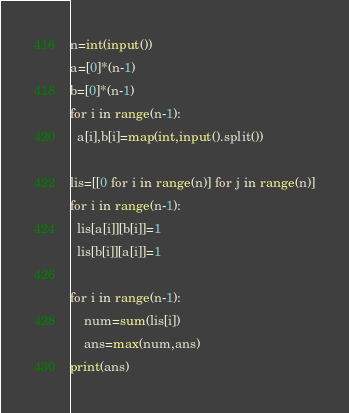<code> <loc_0><loc_0><loc_500><loc_500><_Python_>n=int(input())
a=[0]*(n-1)
b=[0]*(n-1)
for i in range(n-1):
  a[i],b[i]=map(int,input().split())
  
lis=[[0 for i in range(n)] for j in range(n)]
for i in range(n-1):
  lis[a[i]][b[i]]=1
  lis[b[i]][a[i]]=1

for i in range(n-1):
	num=sum(lis[i])
    ans=max(num,ans)
print(ans)</code> 